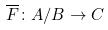Convert formula to latex. <formula><loc_0><loc_0><loc_500><loc_500>\overline { F } \colon A / B \rightarrow C</formula> 